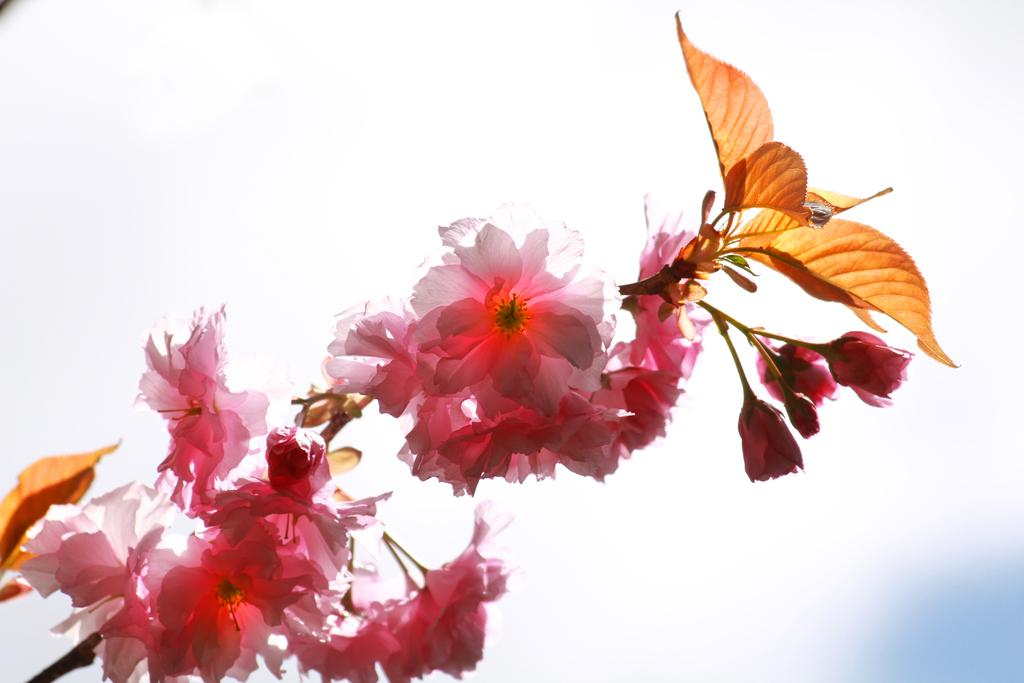What type of plants are visible in the image? There are flowers and leaves in the image. What color is the background of the image? The background of the image is white. How many gloves can be seen in the image? There are no gloves present in the image. What type of fuel is visible in the image? There is no fuel, such as coal, present in the image. 